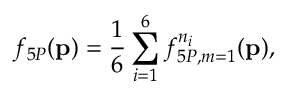Convert formula to latex. <formula><loc_0><loc_0><loc_500><loc_500>f _ { 5 P } ( { p } ) = \frac { 1 } { 6 } \sum _ { i = 1 } ^ { 6 } f _ { 5 P , m = 1 } ^ { n _ { i } } ( { p } ) ,</formula> 